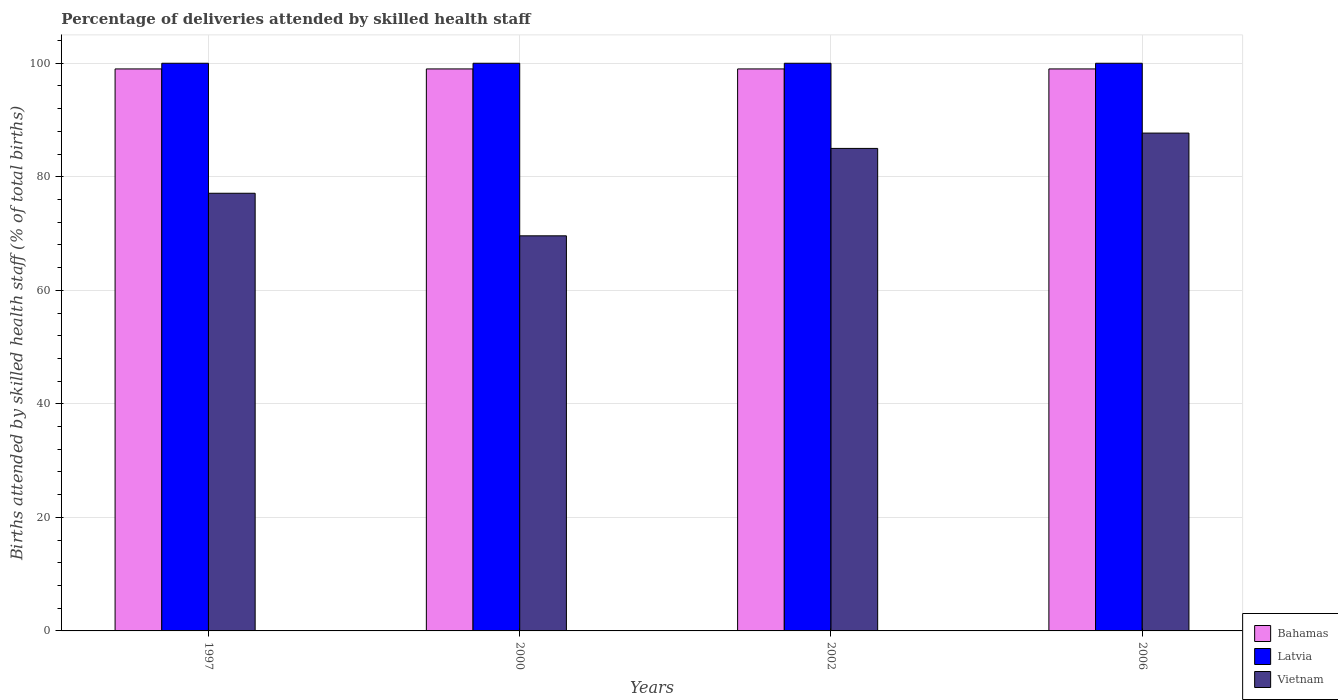Are the number of bars per tick equal to the number of legend labels?
Make the answer very short. Yes. How many bars are there on the 4th tick from the left?
Ensure brevity in your answer.  3. How many bars are there on the 4th tick from the right?
Make the answer very short. 3. What is the label of the 4th group of bars from the left?
Offer a terse response. 2006. In how many cases, is the number of bars for a given year not equal to the number of legend labels?
Keep it short and to the point. 0. What is the percentage of births attended by skilled health staff in Vietnam in 2006?
Ensure brevity in your answer.  87.7. Across all years, what is the maximum percentage of births attended by skilled health staff in Vietnam?
Your response must be concise. 87.7. Across all years, what is the minimum percentage of births attended by skilled health staff in Vietnam?
Provide a succinct answer. 69.6. What is the total percentage of births attended by skilled health staff in Bahamas in the graph?
Your answer should be compact. 396. What is the difference between the percentage of births attended by skilled health staff in Vietnam in 1997 and that in 2002?
Provide a short and direct response. -7.9. In the year 2006, what is the difference between the percentage of births attended by skilled health staff in Latvia and percentage of births attended by skilled health staff in Vietnam?
Offer a terse response. 12.3. In how many years, is the percentage of births attended by skilled health staff in Vietnam greater than 60 %?
Ensure brevity in your answer.  4. What is the ratio of the percentage of births attended by skilled health staff in Vietnam in 1997 to that in 2006?
Make the answer very short. 0.88. Is the percentage of births attended by skilled health staff in Latvia in 2000 less than that in 2002?
Provide a short and direct response. No. What is the difference between the highest and the second highest percentage of births attended by skilled health staff in Latvia?
Provide a short and direct response. 0. What is the difference between the highest and the lowest percentage of births attended by skilled health staff in Bahamas?
Your answer should be very brief. 0. Is the sum of the percentage of births attended by skilled health staff in Vietnam in 2002 and 2006 greater than the maximum percentage of births attended by skilled health staff in Latvia across all years?
Provide a short and direct response. Yes. What does the 1st bar from the left in 2002 represents?
Offer a very short reply. Bahamas. What does the 2nd bar from the right in 2002 represents?
Make the answer very short. Latvia. Are the values on the major ticks of Y-axis written in scientific E-notation?
Give a very brief answer. No. How many legend labels are there?
Ensure brevity in your answer.  3. What is the title of the graph?
Your answer should be compact. Percentage of deliveries attended by skilled health staff. Does "Netherlands" appear as one of the legend labels in the graph?
Provide a short and direct response. No. What is the label or title of the X-axis?
Your answer should be compact. Years. What is the label or title of the Y-axis?
Provide a short and direct response. Births attended by skilled health staff (% of total births). What is the Births attended by skilled health staff (% of total births) of Bahamas in 1997?
Make the answer very short. 99. What is the Births attended by skilled health staff (% of total births) of Vietnam in 1997?
Provide a succinct answer. 77.1. What is the Births attended by skilled health staff (% of total births) in Latvia in 2000?
Give a very brief answer. 100. What is the Births attended by skilled health staff (% of total births) of Vietnam in 2000?
Offer a terse response. 69.6. What is the Births attended by skilled health staff (% of total births) of Latvia in 2006?
Offer a very short reply. 100. What is the Births attended by skilled health staff (% of total births) of Vietnam in 2006?
Your response must be concise. 87.7. Across all years, what is the maximum Births attended by skilled health staff (% of total births) of Latvia?
Keep it short and to the point. 100. Across all years, what is the maximum Births attended by skilled health staff (% of total births) in Vietnam?
Provide a succinct answer. 87.7. Across all years, what is the minimum Births attended by skilled health staff (% of total births) of Vietnam?
Your response must be concise. 69.6. What is the total Births attended by skilled health staff (% of total births) of Bahamas in the graph?
Offer a very short reply. 396. What is the total Births attended by skilled health staff (% of total births) in Latvia in the graph?
Offer a terse response. 400. What is the total Births attended by skilled health staff (% of total births) of Vietnam in the graph?
Make the answer very short. 319.4. What is the difference between the Births attended by skilled health staff (% of total births) of Bahamas in 1997 and that in 2000?
Offer a very short reply. 0. What is the difference between the Births attended by skilled health staff (% of total births) in Vietnam in 1997 and that in 2000?
Your answer should be very brief. 7.5. What is the difference between the Births attended by skilled health staff (% of total births) of Bahamas in 1997 and that in 2002?
Provide a short and direct response. 0. What is the difference between the Births attended by skilled health staff (% of total births) of Bahamas in 1997 and that in 2006?
Offer a terse response. 0. What is the difference between the Births attended by skilled health staff (% of total births) in Vietnam in 1997 and that in 2006?
Ensure brevity in your answer.  -10.6. What is the difference between the Births attended by skilled health staff (% of total births) of Vietnam in 2000 and that in 2002?
Keep it short and to the point. -15.4. What is the difference between the Births attended by skilled health staff (% of total births) in Bahamas in 2000 and that in 2006?
Your response must be concise. 0. What is the difference between the Births attended by skilled health staff (% of total births) in Latvia in 2000 and that in 2006?
Give a very brief answer. 0. What is the difference between the Births attended by skilled health staff (% of total births) in Vietnam in 2000 and that in 2006?
Your response must be concise. -18.1. What is the difference between the Births attended by skilled health staff (% of total births) of Latvia in 2002 and that in 2006?
Give a very brief answer. 0. What is the difference between the Births attended by skilled health staff (% of total births) of Vietnam in 2002 and that in 2006?
Offer a terse response. -2.7. What is the difference between the Births attended by skilled health staff (% of total births) of Bahamas in 1997 and the Births attended by skilled health staff (% of total births) of Latvia in 2000?
Offer a very short reply. -1. What is the difference between the Births attended by skilled health staff (% of total births) in Bahamas in 1997 and the Births attended by skilled health staff (% of total births) in Vietnam in 2000?
Provide a short and direct response. 29.4. What is the difference between the Births attended by skilled health staff (% of total births) of Latvia in 1997 and the Births attended by skilled health staff (% of total births) of Vietnam in 2000?
Your answer should be compact. 30.4. What is the difference between the Births attended by skilled health staff (% of total births) of Latvia in 2000 and the Births attended by skilled health staff (% of total births) of Vietnam in 2002?
Keep it short and to the point. 15. What is the difference between the Births attended by skilled health staff (% of total births) in Bahamas in 2000 and the Births attended by skilled health staff (% of total births) in Latvia in 2006?
Your answer should be compact. -1. What is the difference between the Births attended by skilled health staff (% of total births) of Bahamas in 2000 and the Births attended by skilled health staff (% of total births) of Vietnam in 2006?
Keep it short and to the point. 11.3. What is the difference between the Births attended by skilled health staff (% of total births) in Latvia in 2000 and the Births attended by skilled health staff (% of total births) in Vietnam in 2006?
Ensure brevity in your answer.  12.3. What is the difference between the Births attended by skilled health staff (% of total births) in Bahamas in 2002 and the Births attended by skilled health staff (% of total births) in Vietnam in 2006?
Offer a very short reply. 11.3. What is the average Births attended by skilled health staff (% of total births) of Bahamas per year?
Your answer should be very brief. 99. What is the average Births attended by skilled health staff (% of total births) of Vietnam per year?
Your response must be concise. 79.85. In the year 1997, what is the difference between the Births attended by skilled health staff (% of total births) of Bahamas and Births attended by skilled health staff (% of total births) of Vietnam?
Ensure brevity in your answer.  21.9. In the year 1997, what is the difference between the Births attended by skilled health staff (% of total births) of Latvia and Births attended by skilled health staff (% of total births) of Vietnam?
Ensure brevity in your answer.  22.9. In the year 2000, what is the difference between the Births attended by skilled health staff (% of total births) of Bahamas and Births attended by skilled health staff (% of total births) of Latvia?
Your response must be concise. -1. In the year 2000, what is the difference between the Births attended by skilled health staff (% of total births) of Bahamas and Births attended by skilled health staff (% of total births) of Vietnam?
Your answer should be compact. 29.4. In the year 2000, what is the difference between the Births attended by skilled health staff (% of total births) in Latvia and Births attended by skilled health staff (% of total births) in Vietnam?
Offer a very short reply. 30.4. In the year 2002, what is the difference between the Births attended by skilled health staff (% of total births) in Latvia and Births attended by skilled health staff (% of total births) in Vietnam?
Your response must be concise. 15. In the year 2006, what is the difference between the Births attended by skilled health staff (% of total births) in Bahamas and Births attended by skilled health staff (% of total births) in Latvia?
Your answer should be very brief. -1. In the year 2006, what is the difference between the Births attended by skilled health staff (% of total births) of Bahamas and Births attended by skilled health staff (% of total births) of Vietnam?
Offer a terse response. 11.3. What is the ratio of the Births attended by skilled health staff (% of total births) of Bahamas in 1997 to that in 2000?
Offer a terse response. 1. What is the ratio of the Births attended by skilled health staff (% of total births) of Latvia in 1997 to that in 2000?
Provide a succinct answer. 1. What is the ratio of the Births attended by skilled health staff (% of total births) of Vietnam in 1997 to that in 2000?
Keep it short and to the point. 1.11. What is the ratio of the Births attended by skilled health staff (% of total births) in Vietnam in 1997 to that in 2002?
Ensure brevity in your answer.  0.91. What is the ratio of the Births attended by skilled health staff (% of total births) in Latvia in 1997 to that in 2006?
Your answer should be very brief. 1. What is the ratio of the Births attended by skilled health staff (% of total births) of Vietnam in 1997 to that in 2006?
Give a very brief answer. 0.88. What is the ratio of the Births attended by skilled health staff (% of total births) of Bahamas in 2000 to that in 2002?
Provide a succinct answer. 1. What is the ratio of the Births attended by skilled health staff (% of total births) in Latvia in 2000 to that in 2002?
Provide a short and direct response. 1. What is the ratio of the Births attended by skilled health staff (% of total births) in Vietnam in 2000 to that in 2002?
Your answer should be compact. 0.82. What is the ratio of the Births attended by skilled health staff (% of total births) in Vietnam in 2000 to that in 2006?
Keep it short and to the point. 0.79. What is the ratio of the Births attended by skilled health staff (% of total births) in Bahamas in 2002 to that in 2006?
Offer a very short reply. 1. What is the ratio of the Births attended by skilled health staff (% of total births) of Latvia in 2002 to that in 2006?
Your response must be concise. 1. What is the ratio of the Births attended by skilled health staff (% of total births) in Vietnam in 2002 to that in 2006?
Ensure brevity in your answer.  0.97. What is the difference between the highest and the second highest Births attended by skilled health staff (% of total births) of Bahamas?
Offer a terse response. 0. What is the difference between the highest and the lowest Births attended by skilled health staff (% of total births) of Bahamas?
Keep it short and to the point. 0. What is the difference between the highest and the lowest Births attended by skilled health staff (% of total births) in Latvia?
Provide a short and direct response. 0. What is the difference between the highest and the lowest Births attended by skilled health staff (% of total births) of Vietnam?
Your response must be concise. 18.1. 